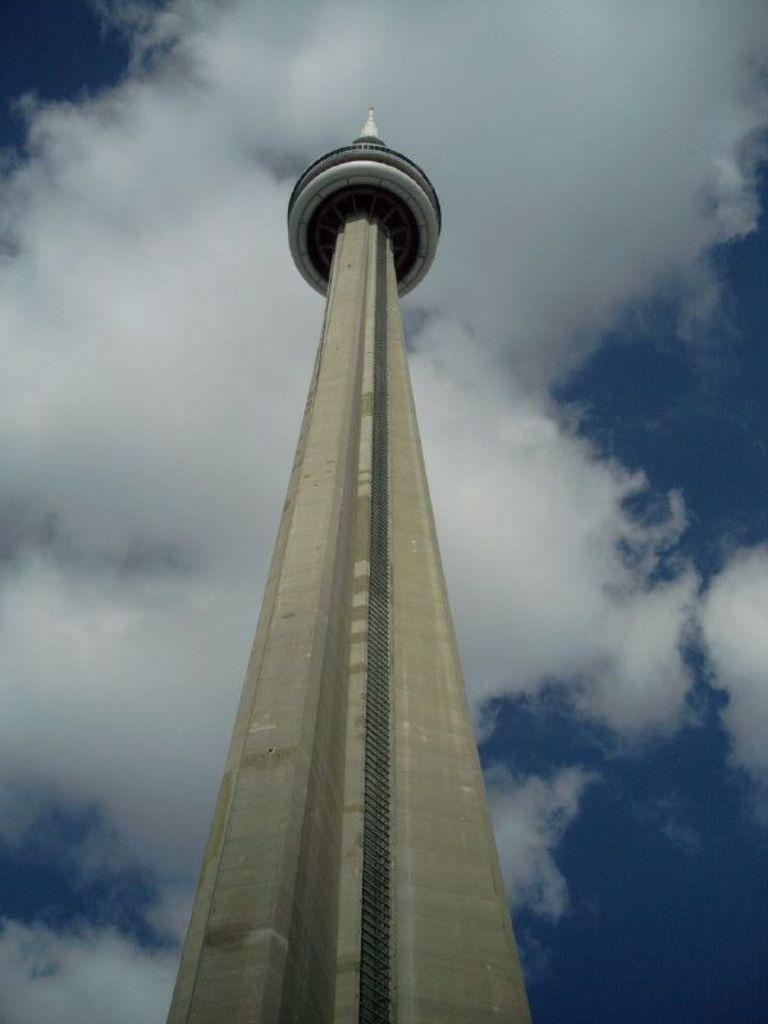How would you summarize this image in a sentence or two? In this picture I can see there is a tower and it is very tall. The sky is clear. 